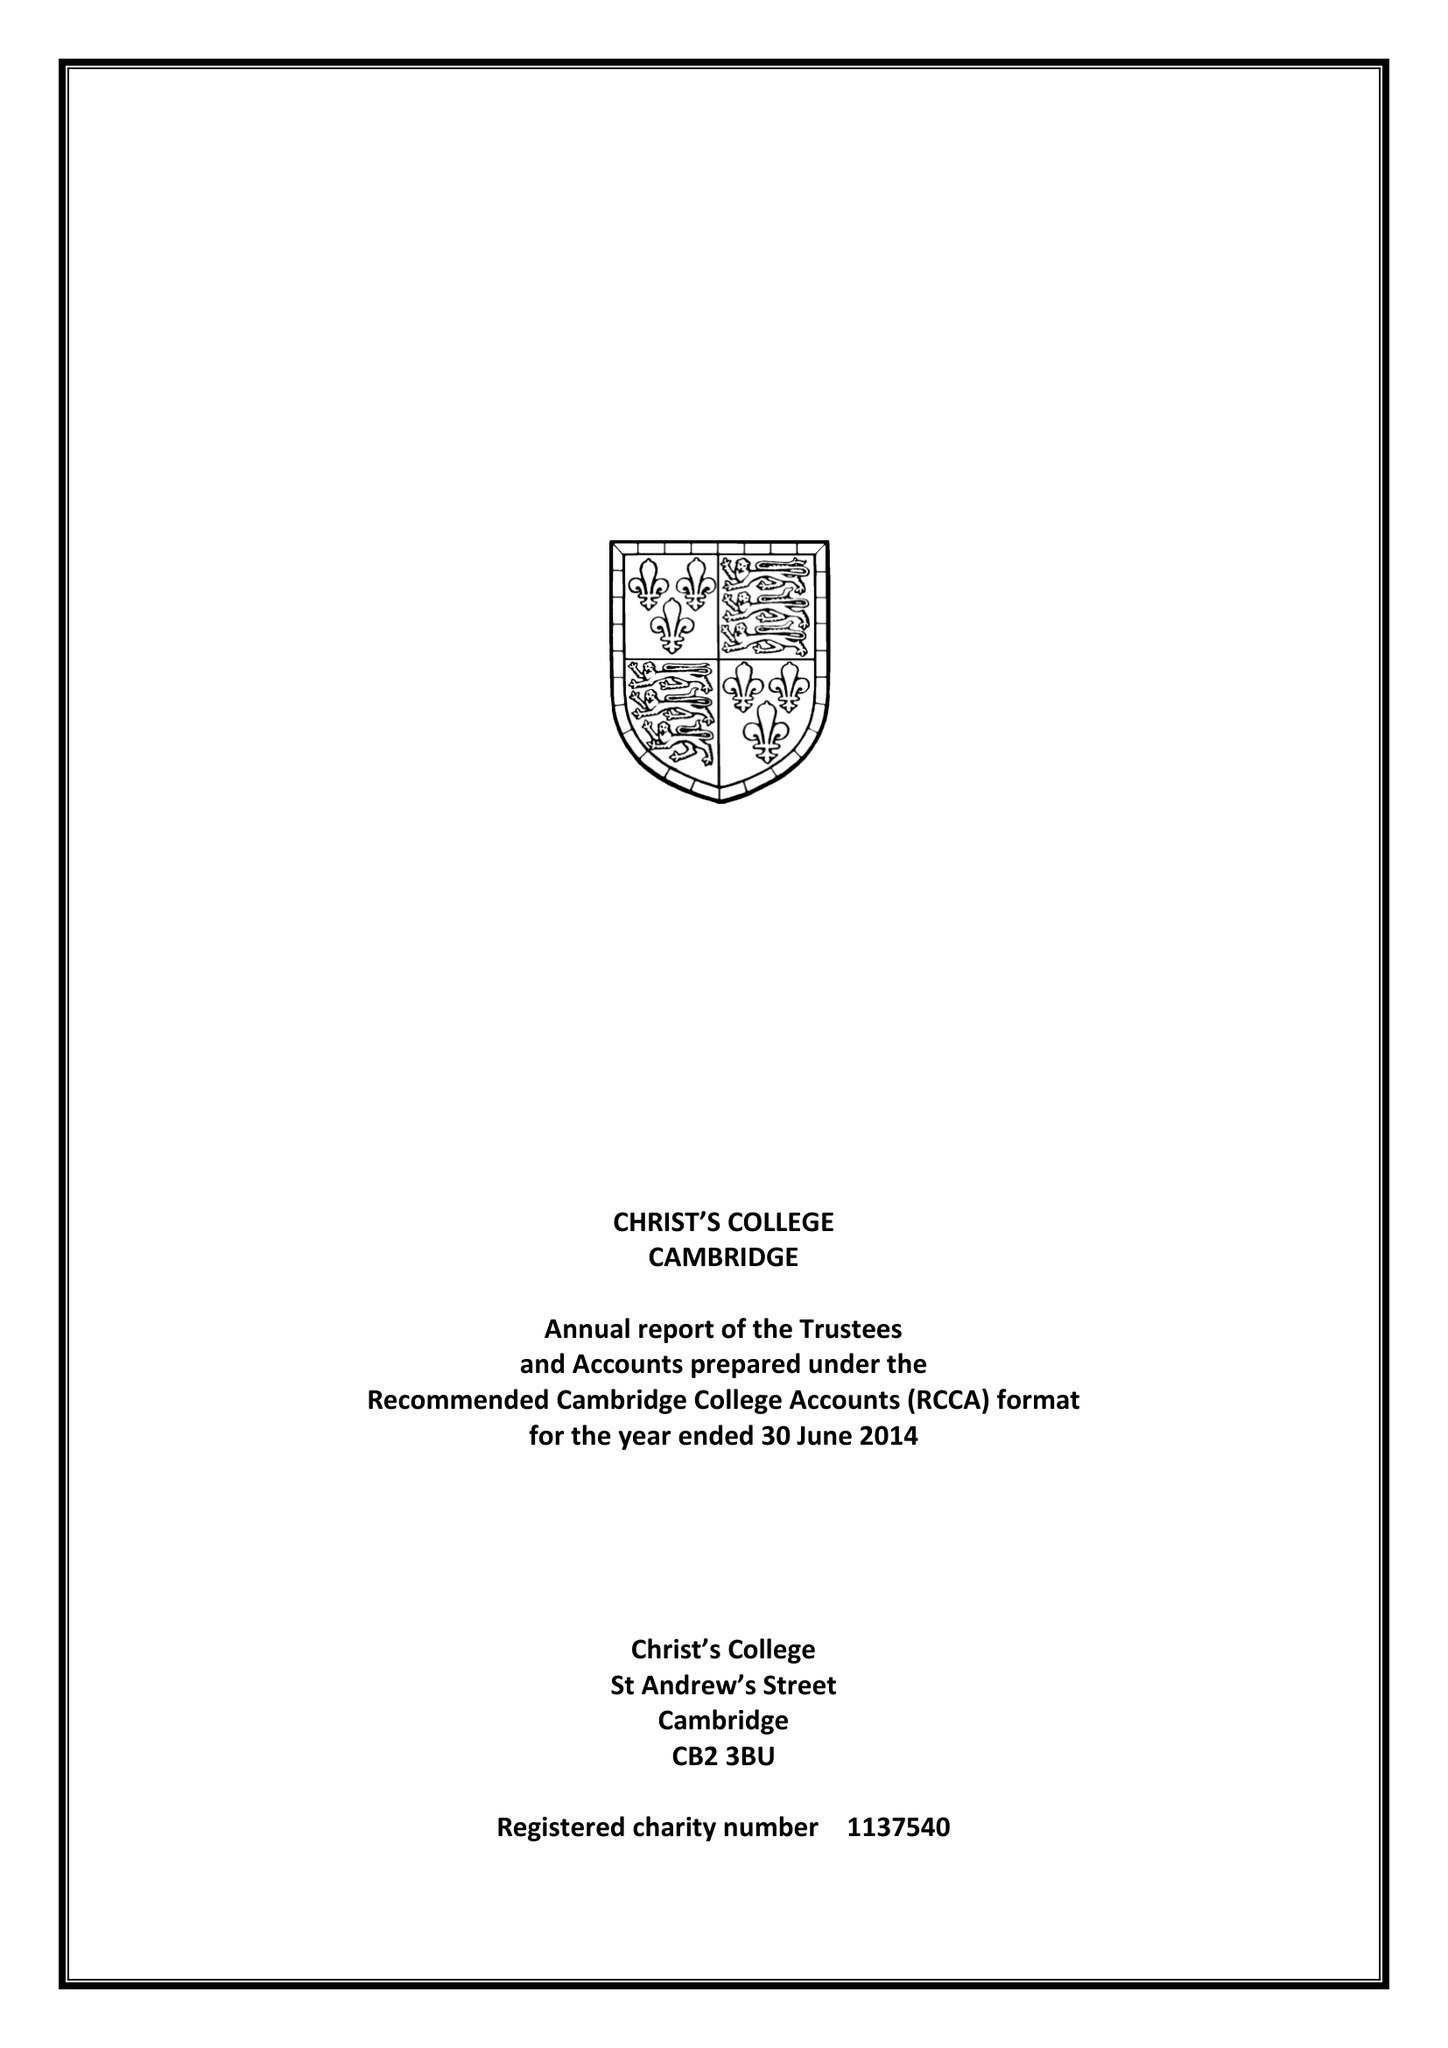What is the value for the spending_annually_in_british_pounds?
Answer the question using a single word or phrase. 9134766.00 